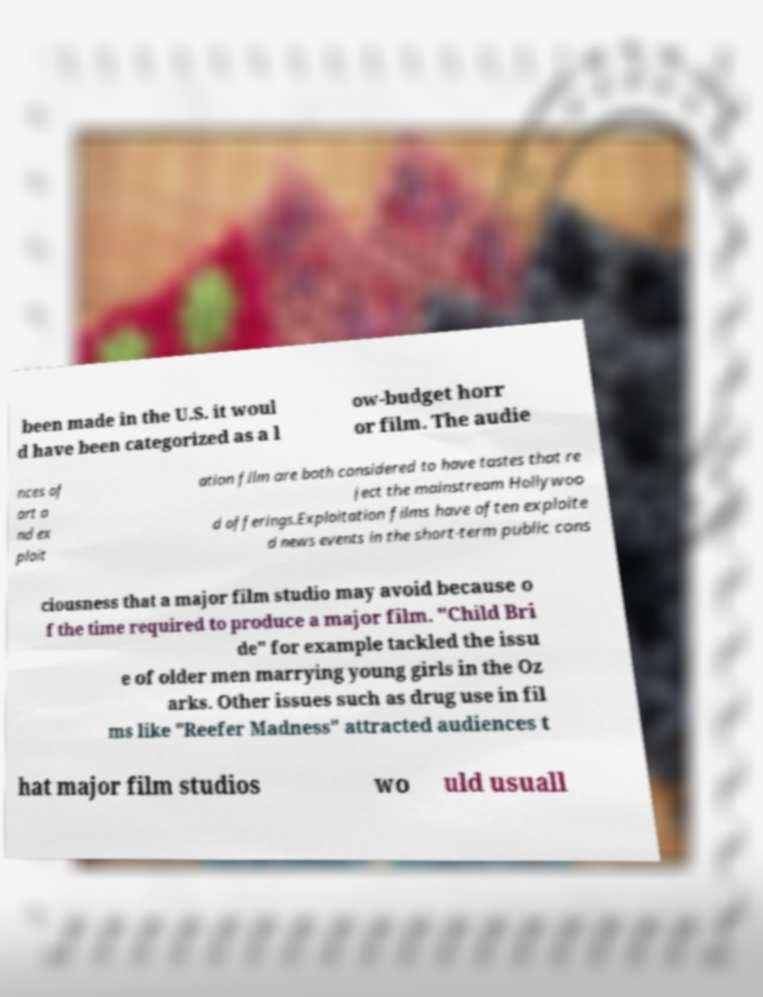What messages or text are displayed in this image? I need them in a readable, typed format. been made in the U.S. it woul d have been categorized as a l ow-budget horr or film. The audie nces of art a nd ex ploit ation film are both considered to have tastes that re ject the mainstream Hollywoo d offerings.Exploitation films have often exploite d news events in the short-term public cons ciousness that a major film studio may avoid because o f the time required to produce a major film. "Child Bri de" for example tackled the issu e of older men marrying young girls in the Oz arks. Other issues such as drug use in fil ms like "Reefer Madness" attracted audiences t hat major film studios wo uld usuall 